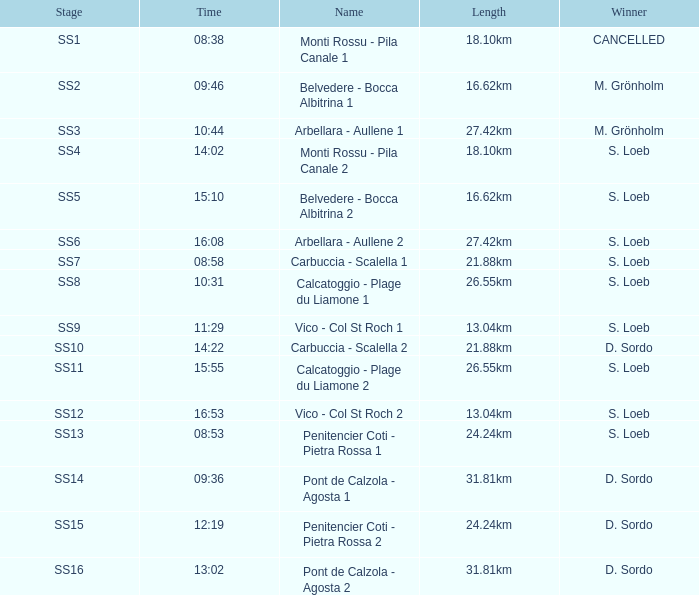What is the Name of the SS11 Stage? Calcatoggio - Plage du Liamone 2. 